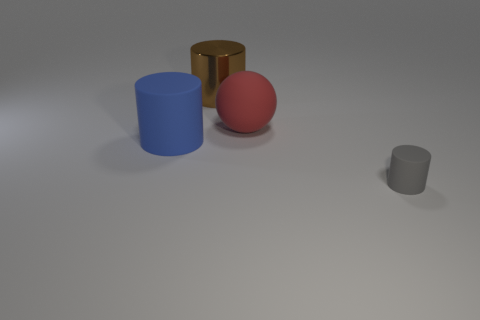Add 2 red matte balls. How many objects exist? 6 Subtract all matte cylinders. How many cylinders are left? 1 Subtract all spheres. How many objects are left? 3 Subtract all large matte things. Subtract all brown metal things. How many objects are left? 1 Add 3 large blue matte objects. How many large blue matte objects are left? 4 Add 1 large blue matte cylinders. How many large blue matte cylinders exist? 2 Subtract 0 green cubes. How many objects are left? 4 Subtract all cyan cylinders. Subtract all purple cubes. How many cylinders are left? 3 